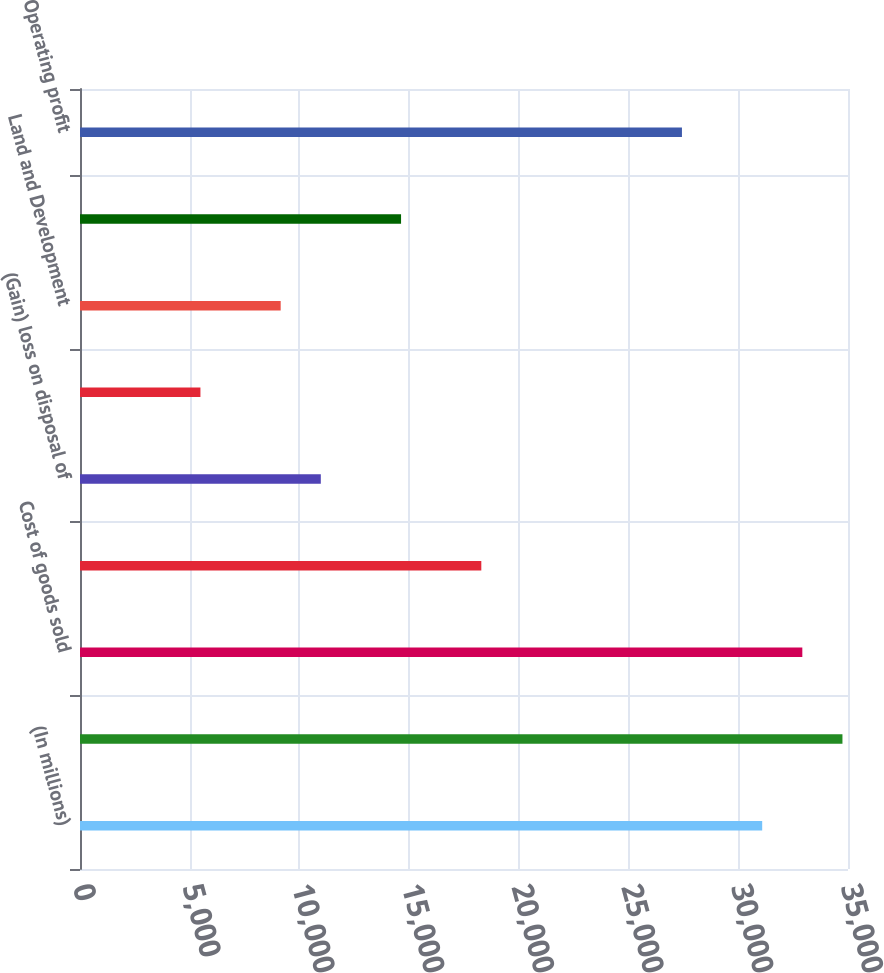Convert chart. <chart><loc_0><loc_0><loc_500><loc_500><bar_chart><fcel>(In millions)<fcel>Net sales<fcel>Cost of goods sold<fcel>Selling general and<fcel>(Gain) loss on disposal of<fcel>Multiemployer pension<fcel>Land and Development<fcel>Restructuring and other costs<fcel>Operating profit<nl><fcel>31089.6<fcel>34746.9<fcel>32918.3<fcel>18289<fcel>10974.4<fcel>5488.38<fcel>9145.7<fcel>14631.7<fcel>27432.3<nl></chart> 